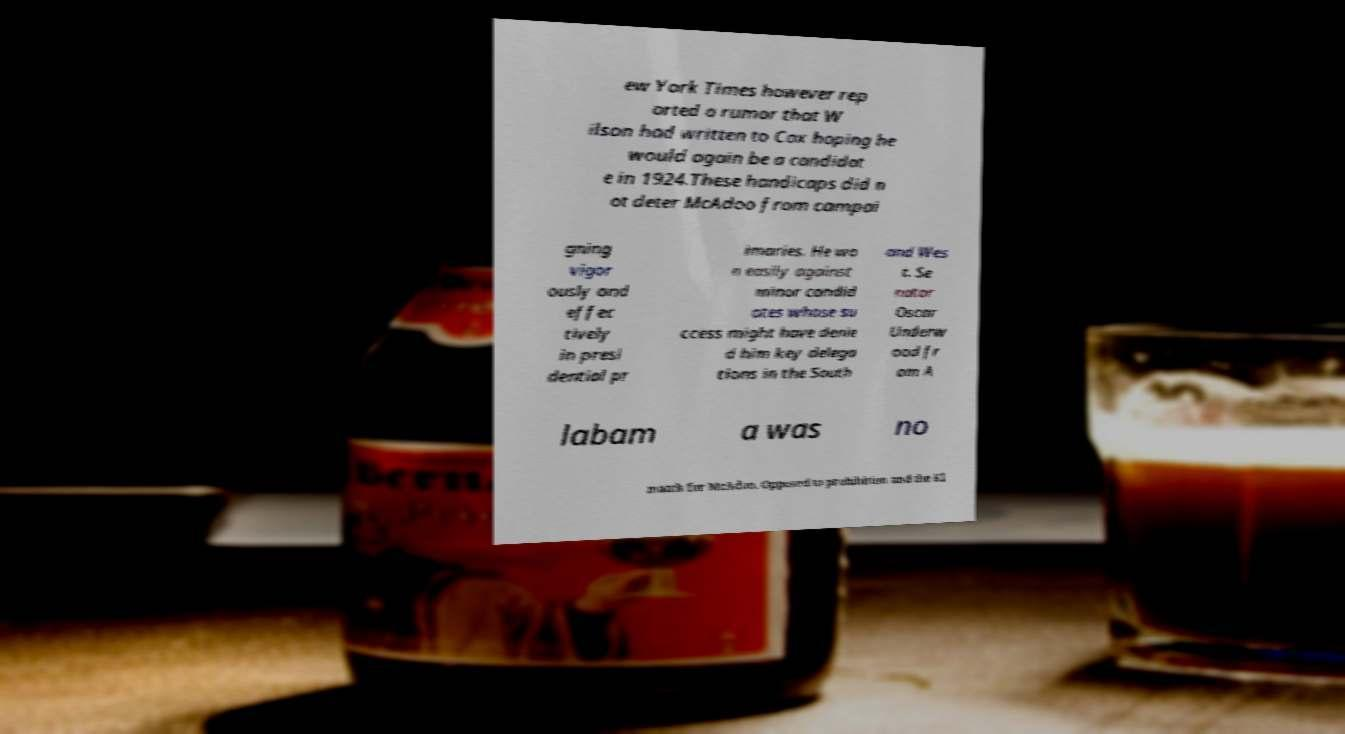For documentation purposes, I need the text within this image transcribed. Could you provide that? ew York Times however rep orted a rumor that W ilson had written to Cox hoping he would again be a candidat e in 1924.These handicaps did n ot deter McAdoo from campai gning vigor ously and effec tively in presi dential pr imaries. He wo n easily against minor candid ates whose su ccess might have denie d him key delega tions in the South and Wes t. Se nator Oscar Underw ood fr om A labam a was no match for McAdoo. Opposed to prohibition and the Kl 